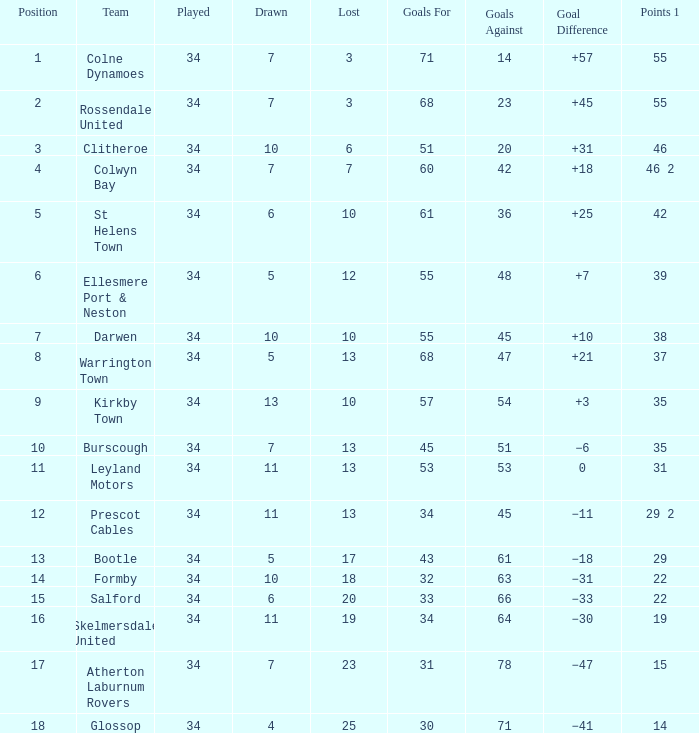How many Drawn have a Lost smaller than 25, and a Goal Difference of +7, and a Played larger than 34? 0.0. 